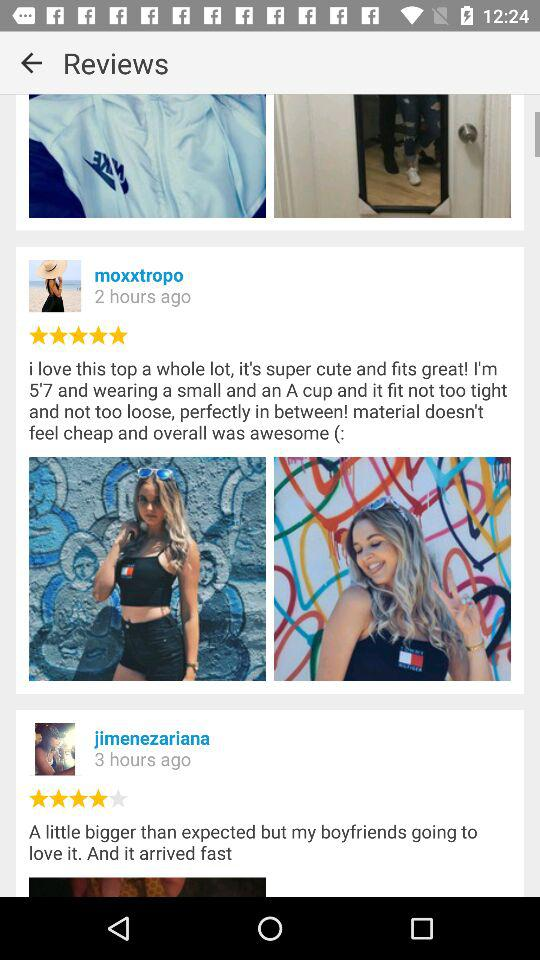How many ratings are there for jimenezariana's post? The rating is 4 stars. 